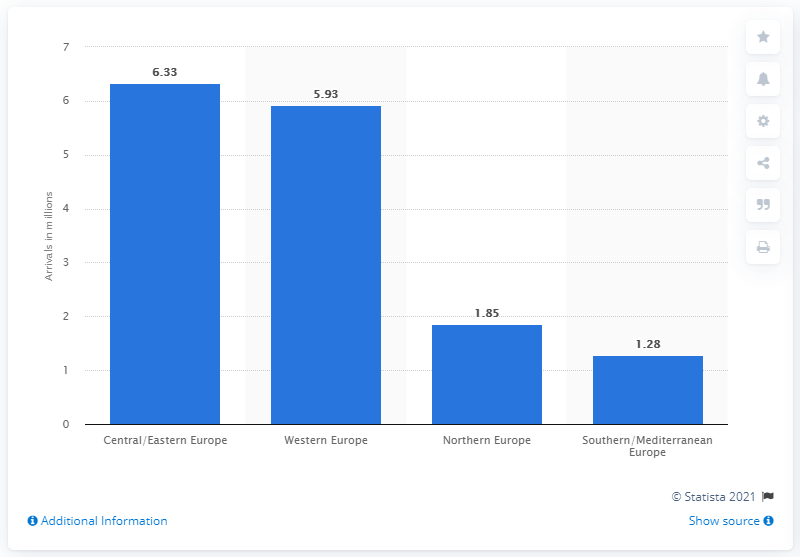Specify some key components in this picture. In 2019, Western Europe had approximately 5.93 outbound trips from China. In 2019, approximately 6.33 million Chinese tourists visited Central and Eastern Europe. In 2019, the region that was most visited by Chinese tourists was Central/Eastern Europe. 